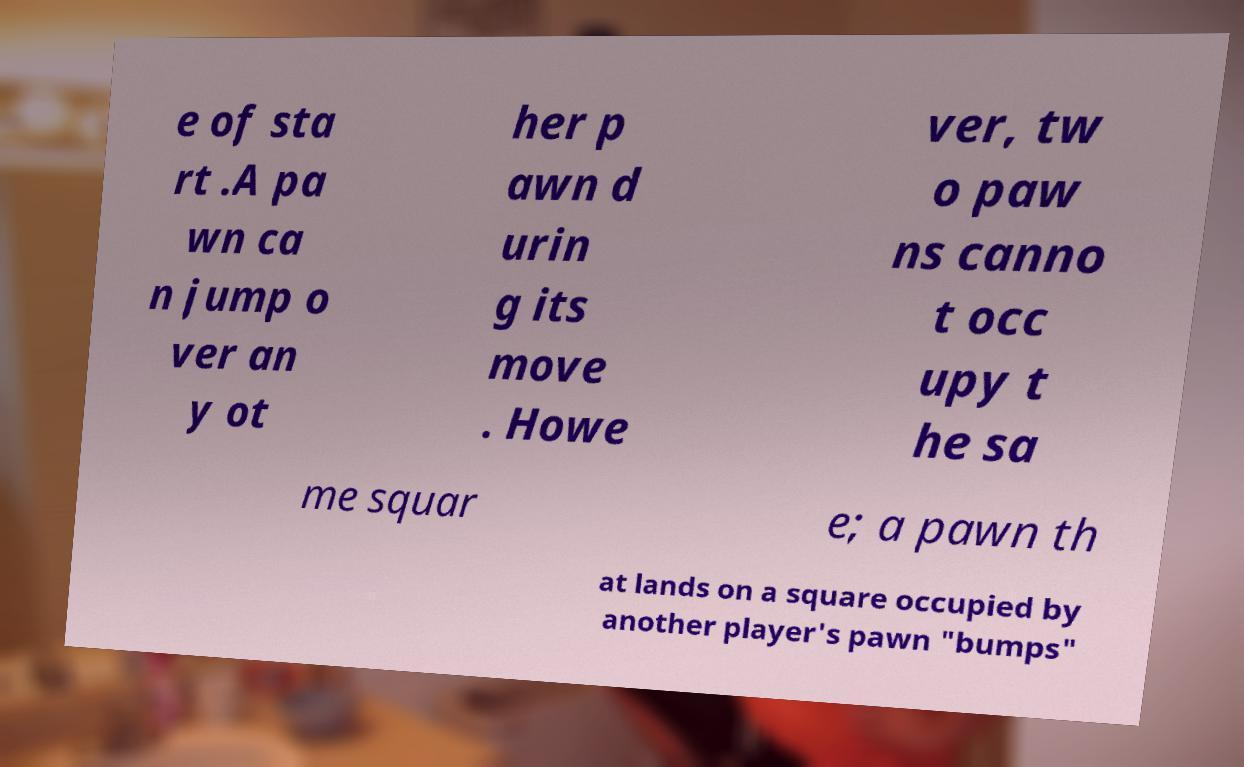Can you accurately transcribe the text from the provided image for me? e of sta rt .A pa wn ca n jump o ver an y ot her p awn d urin g its move . Howe ver, tw o paw ns canno t occ upy t he sa me squar e; a pawn th at lands on a square occupied by another player's pawn "bumps" 